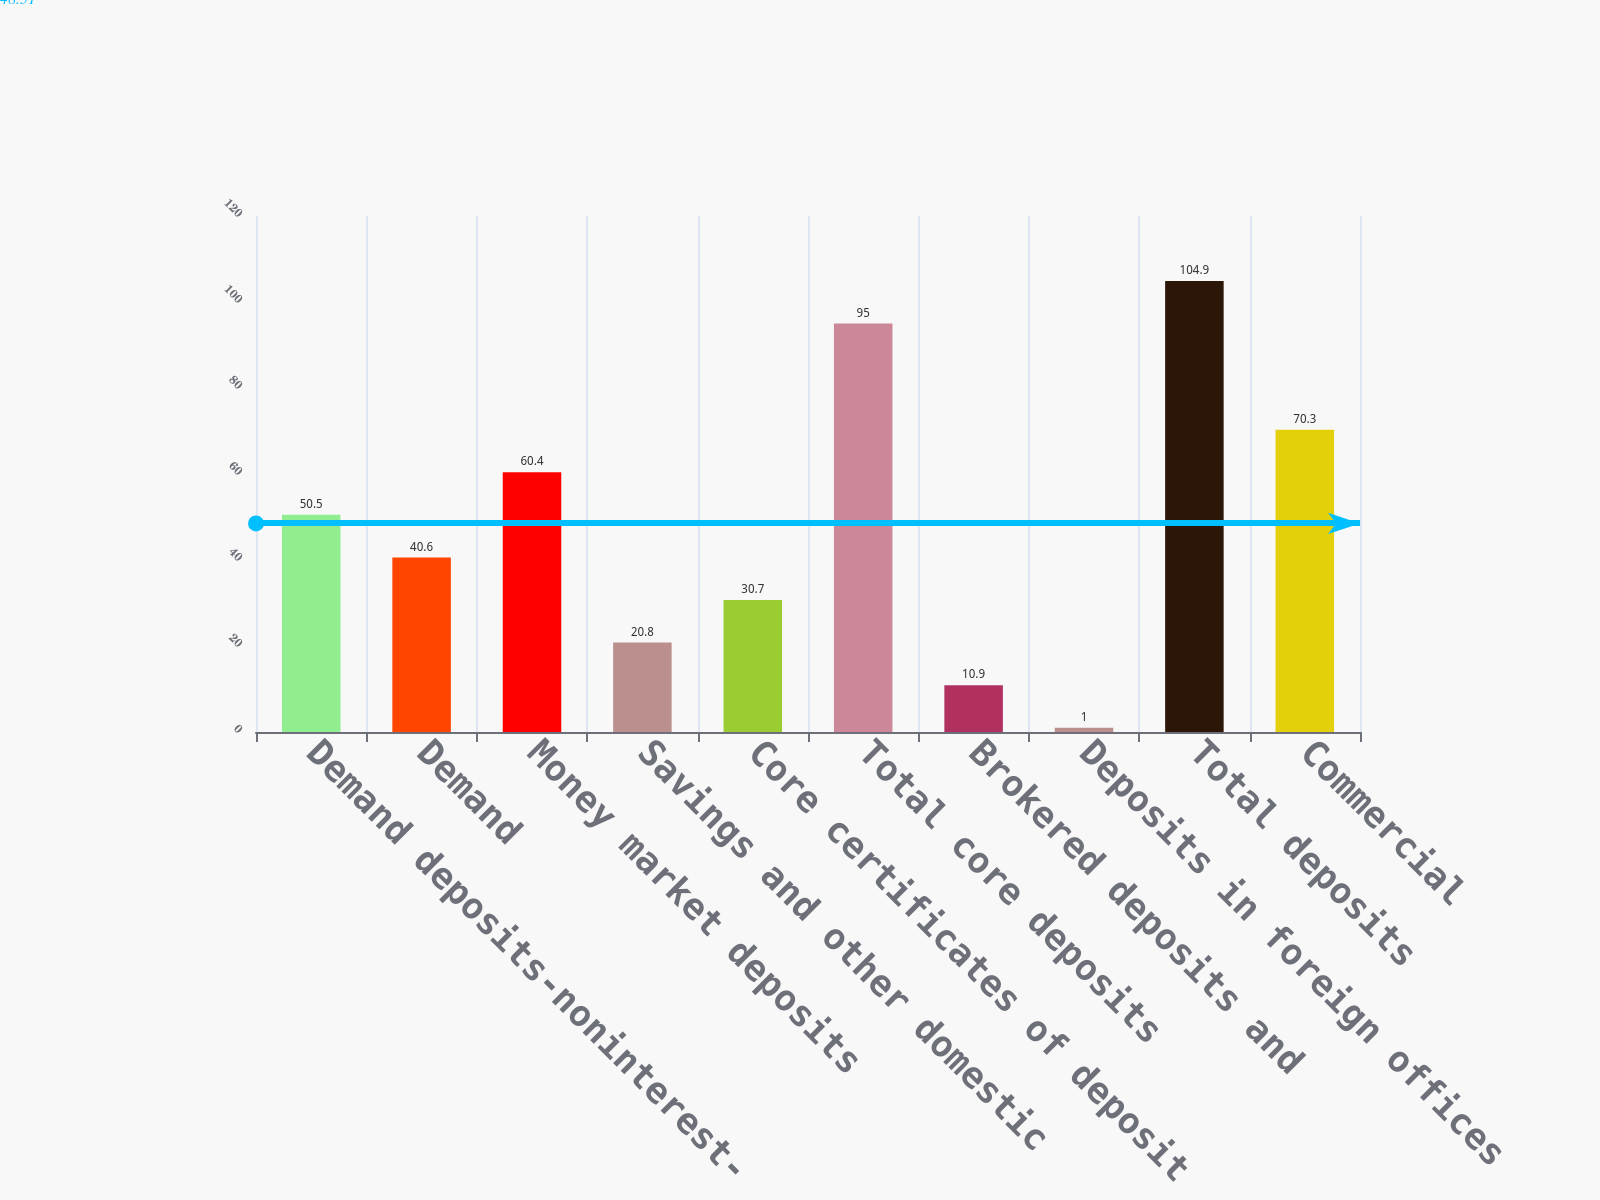Convert chart. <chart><loc_0><loc_0><loc_500><loc_500><bar_chart><fcel>Demand deposits-noninterest-<fcel>Demand<fcel>Money market deposits<fcel>Savings and other domestic<fcel>Core certificates of deposit<fcel>Total core deposits<fcel>Brokered deposits and<fcel>Deposits in foreign offices<fcel>Total deposits<fcel>Commercial<nl><fcel>50.5<fcel>40.6<fcel>60.4<fcel>20.8<fcel>30.7<fcel>95<fcel>10.9<fcel>1<fcel>104.9<fcel>70.3<nl></chart> 